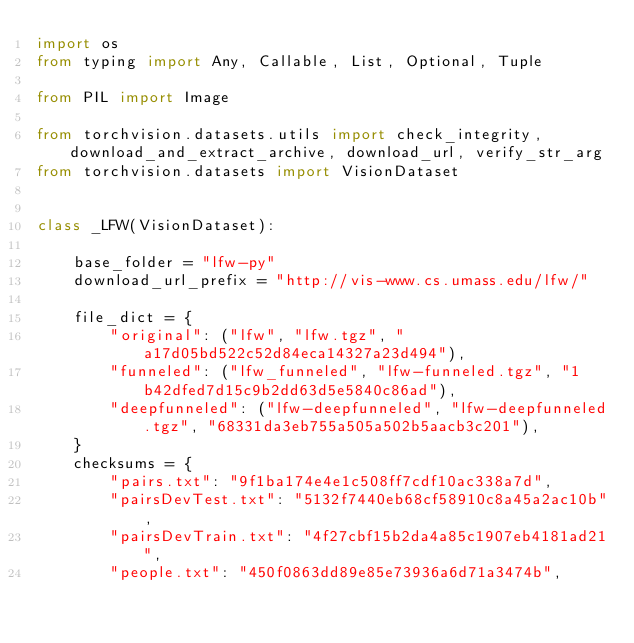Convert code to text. <code><loc_0><loc_0><loc_500><loc_500><_Python_>import os
from typing import Any, Callable, List, Optional, Tuple

from PIL import Image

from torchvision.datasets.utils import check_integrity, download_and_extract_archive, download_url, verify_str_arg
from torchvision.datasets import VisionDataset


class _LFW(VisionDataset):

    base_folder = "lfw-py"
    download_url_prefix = "http://vis-www.cs.umass.edu/lfw/"

    file_dict = {
        "original": ("lfw", "lfw.tgz", "a17d05bd522c52d84eca14327a23d494"),
        "funneled": ("lfw_funneled", "lfw-funneled.tgz", "1b42dfed7d15c9b2dd63d5e5840c86ad"),
        "deepfunneled": ("lfw-deepfunneled", "lfw-deepfunneled.tgz", "68331da3eb755a505a502b5aacb3c201"),
    }
    checksums = {
        "pairs.txt": "9f1ba174e4e1c508ff7cdf10ac338a7d",
        "pairsDevTest.txt": "5132f7440eb68cf58910c8a45a2ac10b",
        "pairsDevTrain.txt": "4f27cbf15b2da4a85c1907eb4181ad21",
        "people.txt": "450f0863dd89e85e73936a6d71a3474b",</code> 